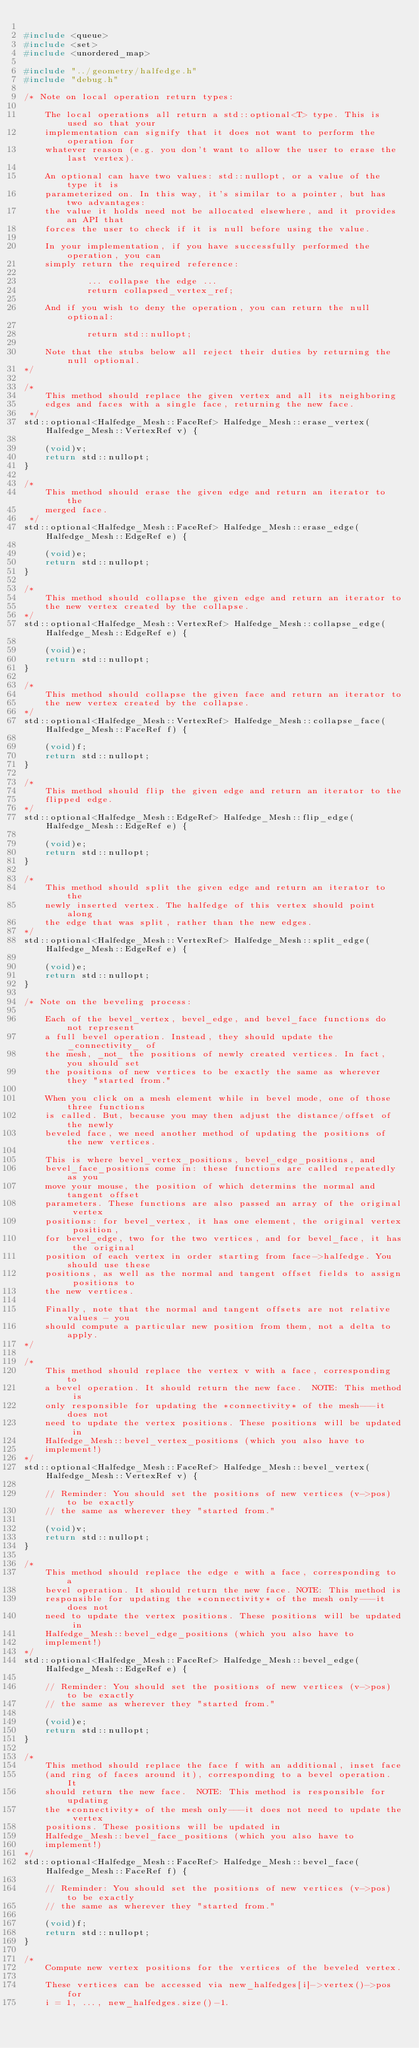<code> <loc_0><loc_0><loc_500><loc_500><_C++_>
#include <queue>
#include <set>
#include <unordered_map>

#include "../geometry/halfedge.h"
#include "debug.h"

/* Note on local operation return types:

    The local operations all return a std::optional<T> type. This is used so that your
    implementation can signify that it does not want to perform the operation for
    whatever reason (e.g. you don't want to allow the user to erase the last vertex).

    An optional can have two values: std::nullopt, or a value of the type it is
    parameterized on. In this way, it's similar to a pointer, but has two advantages:
    the value it holds need not be allocated elsewhere, and it provides an API that
    forces the user to check if it is null before using the value.

    In your implementation, if you have successfully performed the operation, you can
    simply return the required reference:

            ... collapse the edge ...
            return collapsed_vertex_ref;

    And if you wish to deny the operation, you can return the null optional:

            return std::nullopt;

    Note that the stubs below all reject their duties by returning the null optional.
*/

/*
    This method should replace the given vertex and all its neighboring
    edges and faces with a single face, returning the new face.
 */
std::optional<Halfedge_Mesh::FaceRef> Halfedge_Mesh::erase_vertex(Halfedge_Mesh::VertexRef v) {

    (void)v;
    return std::nullopt;
}

/*
    This method should erase the given edge and return an iterator to the
    merged face.
 */
std::optional<Halfedge_Mesh::FaceRef> Halfedge_Mesh::erase_edge(Halfedge_Mesh::EdgeRef e) {

    (void)e;
    return std::nullopt;
}

/*
    This method should collapse the given edge and return an iterator to
    the new vertex created by the collapse.
*/
std::optional<Halfedge_Mesh::VertexRef> Halfedge_Mesh::collapse_edge(Halfedge_Mesh::EdgeRef e) {

    (void)e;
    return std::nullopt;
}

/*
    This method should collapse the given face and return an iterator to
    the new vertex created by the collapse.
*/
std::optional<Halfedge_Mesh::VertexRef> Halfedge_Mesh::collapse_face(Halfedge_Mesh::FaceRef f) {

    (void)f;
    return std::nullopt;
}

/*
    This method should flip the given edge and return an iterator to the
    flipped edge.
*/
std::optional<Halfedge_Mesh::EdgeRef> Halfedge_Mesh::flip_edge(Halfedge_Mesh::EdgeRef e) {

    (void)e;
    return std::nullopt;
}

/*
    This method should split the given edge and return an iterator to the
    newly inserted vertex. The halfedge of this vertex should point along
    the edge that was split, rather than the new edges.
*/
std::optional<Halfedge_Mesh::VertexRef> Halfedge_Mesh::split_edge(Halfedge_Mesh::EdgeRef e) {

    (void)e;
    return std::nullopt;
}

/* Note on the beveling process:

    Each of the bevel_vertex, bevel_edge, and bevel_face functions do not represent
    a full bevel operation. Instead, they should update the _connectivity_ of
    the mesh, _not_ the positions of newly created vertices. In fact, you should set
    the positions of new vertices to be exactly the same as wherever they "started from."

    When you click on a mesh element while in bevel mode, one of those three functions
    is called. But, because you may then adjust the distance/offset of the newly
    beveled face, we need another method of updating the positions of the new vertices.

    This is where bevel_vertex_positions, bevel_edge_positions, and
    bevel_face_positions come in: these functions are called repeatedly as you
    move your mouse, the position of which determins the normal and tangent offset
    parameters. These functions are also passed an array of the original vertex
    positions: for bevel_vertex, it has one element, the original vertex position,
    for bevel_edge, two for the two vertices, and for bevel_face, it has the original
    position of each vertex in order starting from face->halfedge. You should use these 
    positions, as well as the normal and tangent offset fields to assign positions to 
    the new vertices.

    Finally, note that the normal and tangent offsets are not relative values - you
    should compute a particular new position from them, not a delta to apply.
*/

/*
    This method should replace the vertex v with a face, corresponding to
    a bevel operation. It should return the new face.  NOTE: This method is
    only responsible for updating the *connectivity* of the mesh---it does not
    need to update the vertex positions. These positions will be updated in
    Halfedge_Mesh::bevel_vertex_positions (which you also have to
    implement!)
*/
std::optional<Halfedge_Mesh::FaceRef> Halfedge_Mesh::bevel_vertex(Halfedge_Mesh::VertexRef v) {

    // Reminder: You should set the positions of new vertices (v->pos) to be exactly
    // the same as wherever they "started from."

    (void)v;
    return std::nullopt;
}

/*
    This method should replace the edge e with a face, corresponding to a
    bevel operation. It should return the new face. NOTE: This method is
    responsible for updating the *connectivity* of the mesh only---it does not
    need to update the vertex positions. These positions will be updated in
    Halfedge_Mesh::bevel_edge_positions (which you also have to
    implement!)
*/
std::optional<Halfedge_Mesh::FaceRef> Halfedge_Mesh::bevel_edge(Halfedge_Mesh::EdgeRef e) {

    // Reminder: You should set the positions of new vertices (v->pos) to be exactly
    // the same as wherever they "started from."

    (void)e;
    return std::nullopt;
}

/*
    This method should replace the face f with an additional, inset face
    (and ring of faces around it), corresponding to a bevel operation. It
    should return the new face.  NOTE: This method is responsible for updating
    the *connectivity* of the mesh only---it does not need to update the vertex
    positions. These positions will be updated in
    Halfedge_Mesh::bevel_face_positions (which you also have to
    implement!)
*/
std::optional<Halfedge_Mesh::FaceRef> Halfedge_Mesh::bevel_face(Halfedge_Mesh::FaceRef f) {

    // Reminder: You should set the positions of new vertices (v->pos) to be exactly
    // the same as wherever they "started from."

    (void)f;
    return std::nullopt;
}

/*
    Compute new vertex positions for the vertices of the beveled vertex.

    These vertices can be accessed via new_halfedges[i]->vertex()->pos for
    i = 1, ..., new_halfedges.size()-1.</code> 